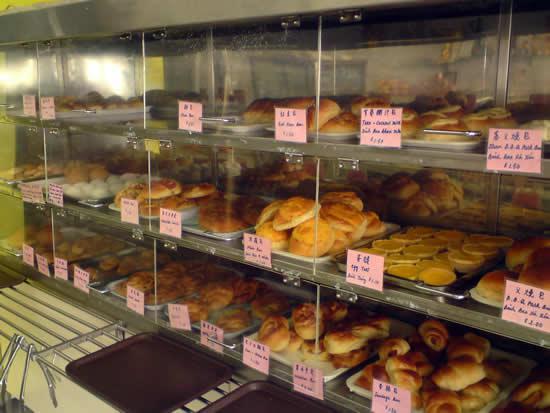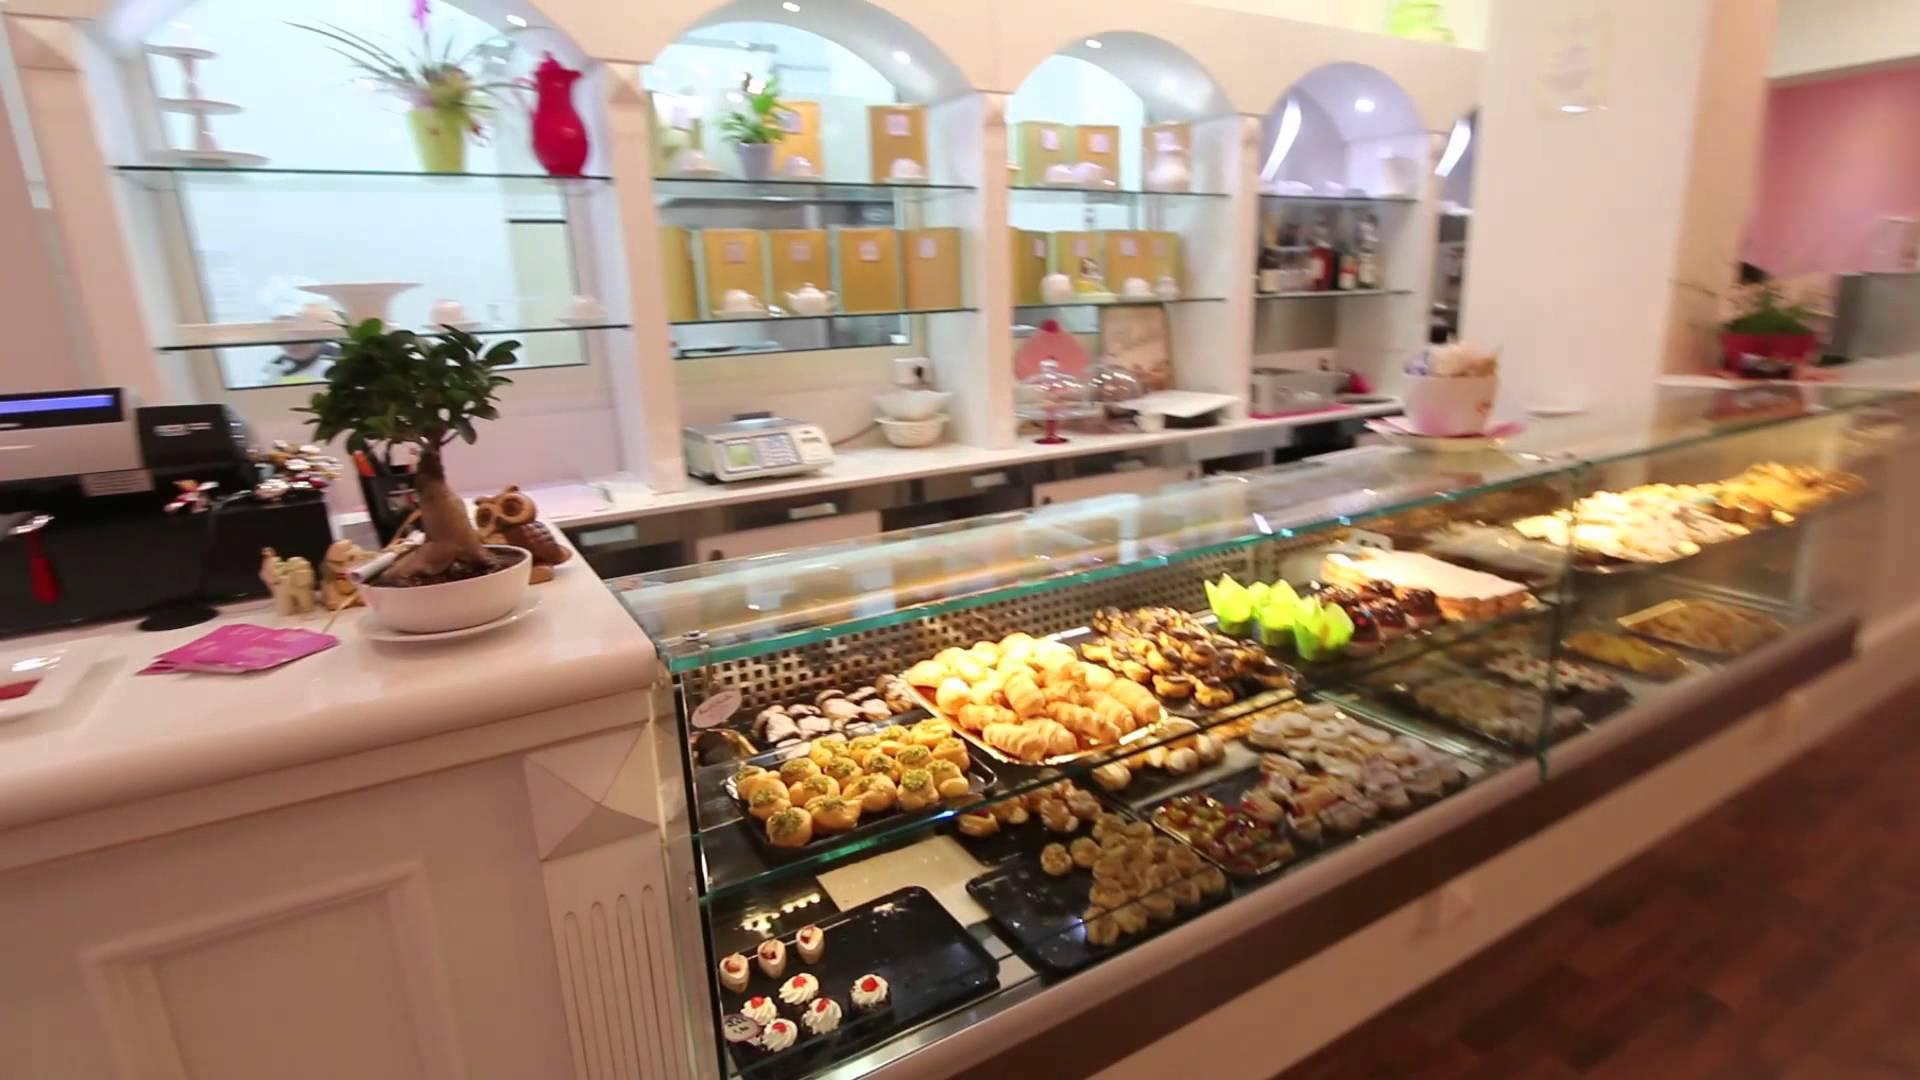The first image is the image on the left, the second image is the image on the right. For the images displayed, is the sentence "Floral arrangements are on a shelf somewhere above a glass display of bakery items." factually correct? Answer yes or no. Yes. The first image is the image on the left, the second image is the image on the right. For the images shown, is this caption "There are labels for each group of pastries in at least one of the images." true? Answer yes or no. Yes. 